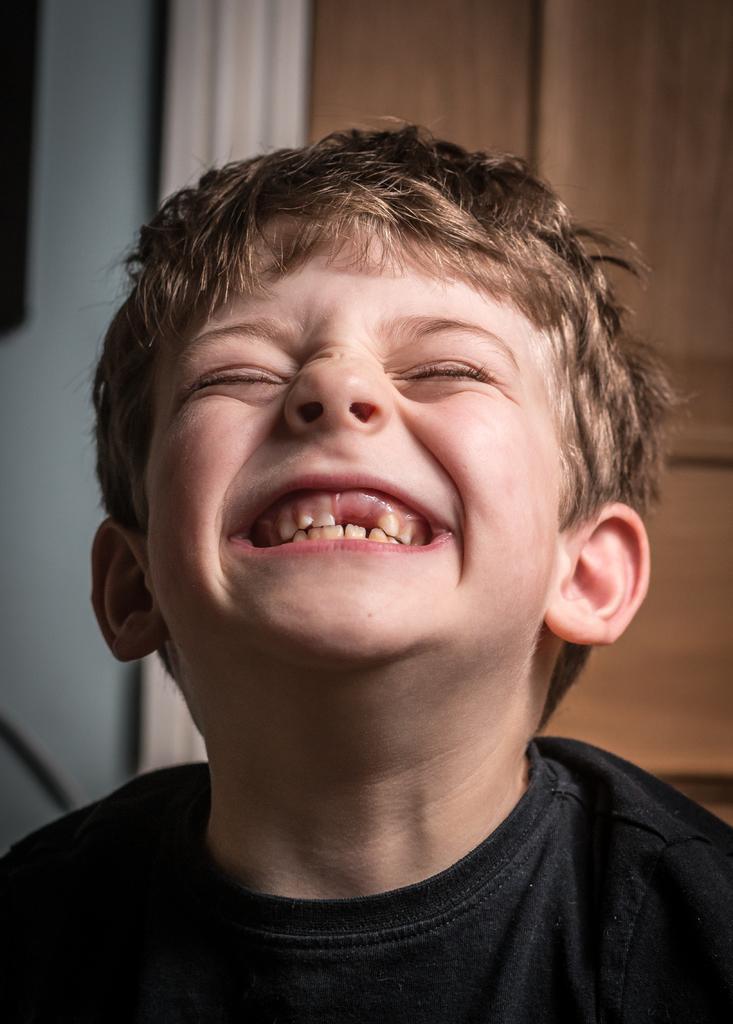Describe this image in one or two sentences. In this image I can see a kid. In the background, I can see the wall. 